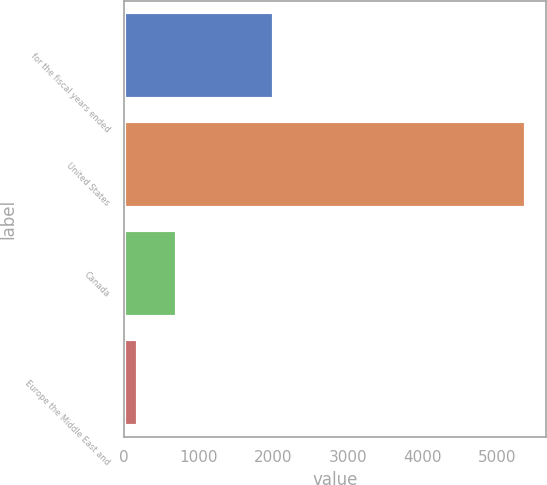Convert chart. <chart><loc_0><loc_0><loc_500><loc_500><bar_chart><fcel>for the fiscal years ended<fcel>United States<fcel>Canada<fcel>Europe the Middle East and<nl><fcel>2013<fcel>5389.5<fcel>704.91<fcel>184.4<nl></chart> 